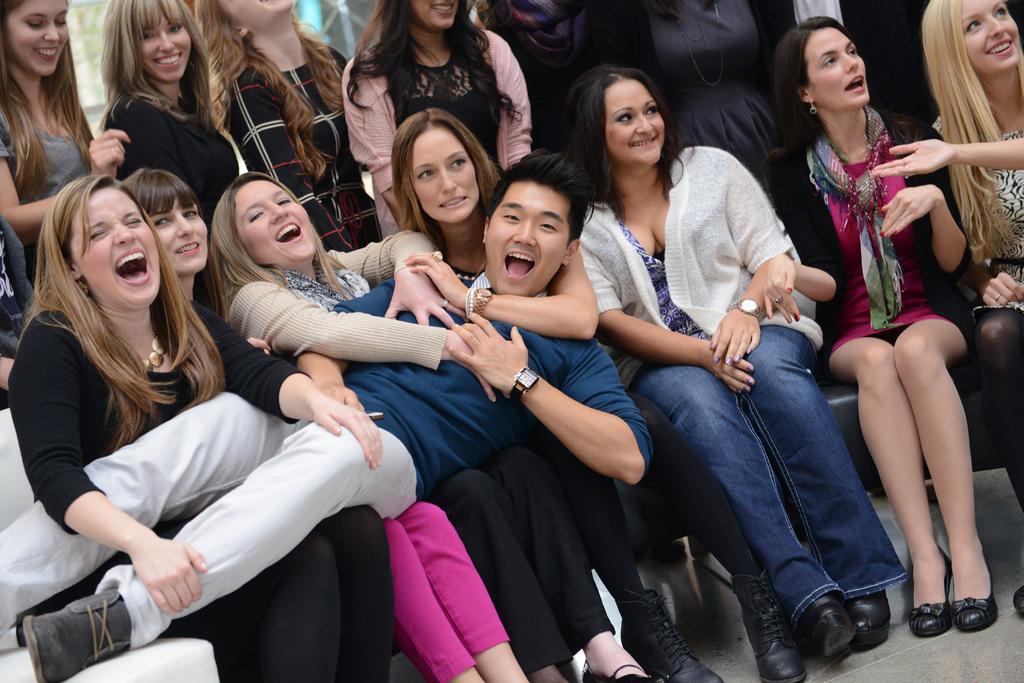Can you describe this image briefly? In the image there are many women sitting on chairs and holding a man and behind there are few women standing. 